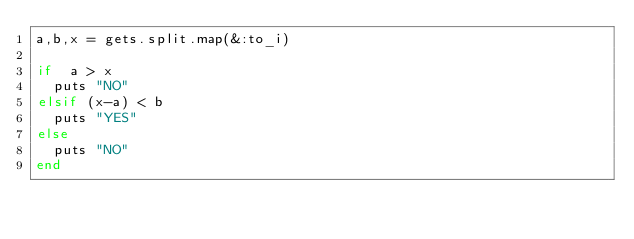<code> <loc_0><loc_0><loc_500><loc_500><_Ruby_>a,b,x = gets.split.map(&:to_i)

if  a > x
  puts "NO"
elsif (x-a) < b
  puts "YES"
else
  puts "NO"
end
</code> 